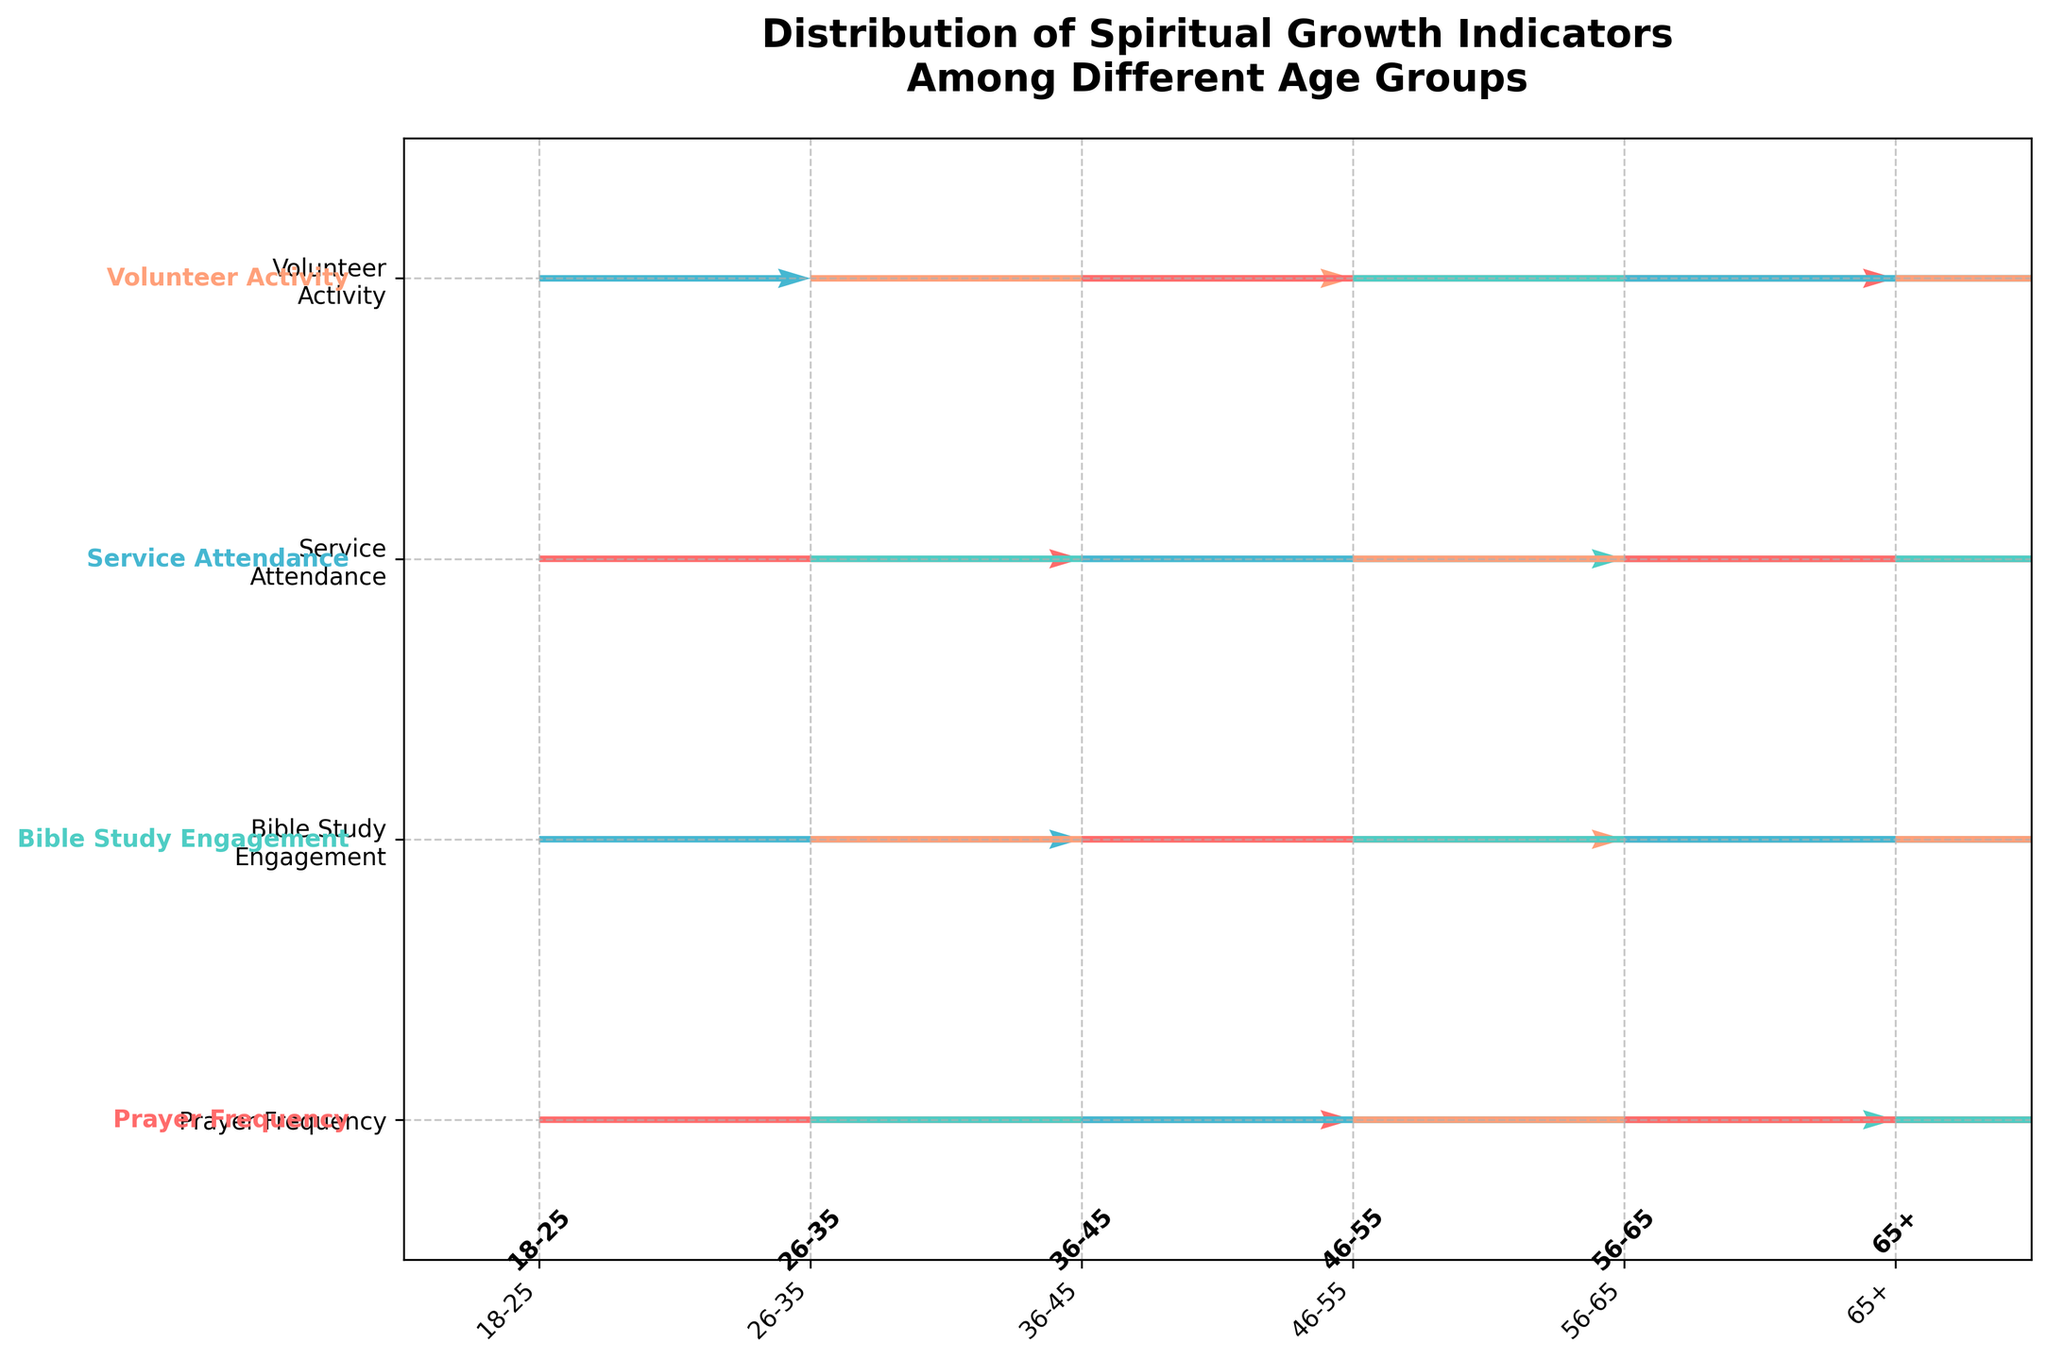What is the title of the figure? The title of the figure is at the top and is usually bolded for emphasis. The title specifically states what the figure is about.
Answer: Distribution of Spiritual Growth Indicators Among Different Age Groups How many age groups are represented in the figure? The age groups are listed along the x-axis. You can count these groups to determine the number of age groups represented.
Answer: 6 Which age group has the highest Volunteer Activity? The arrows in the quiver plot that point highest vertically on the Volunteer Activity row indicate the highest score. Here, it’s best to locate the longest arrow in that row.
Answer: 65+ Which age group shows the lowest Bible Study Engagement? Look at the row for Bible Study Engagement and find the shortest arrow. The age group corresponding to this arrow at the base is the one with the lowest engagement.
Answer: 18-25 Compare the Prayer Frequency of age groups 36-45 and 56-65. Which one is higher? Find the arrows pointing upward in the Prayer Frequency row for both age groups and compare their lengths.
Answer: 56-65 What's the overall trend in Service Attendance from the youngest to the oldest age group? Examine the arrows in the Service Attendance row sequentially from the youngest to oldest age group. Observe if they generally increase, decrease, or remain constant.
Answer: Increasing How many spiritual growth indicators does the age group 46-55 have at maximum score? Count how many arrows reach the highest point in the grid corresponding to the age group 46-55.
Answer: 1 Which indicator shows the most significant increase between age groups 18-25 and 26-35? Compare the length of arrows for each indicator between these two age groups and identify the indicator with the most considerable increase.
Answer: Prayer Frequency What is the average level of Volunteer Activity across all age groups? Add up the values of Volunteer Activity for all age groups and divide by the number of age groups. 1 + 2 + 3 + 4 + 5 + 6 = 21; 21 / 6 = 3.5
Answer: 3.5 Is there any age group where all indicators show a progressive increase without any exception? Check each age group to see if, from one indicator to the next, there is no downward or stagnant movement, only increasing values.
Answer: No 